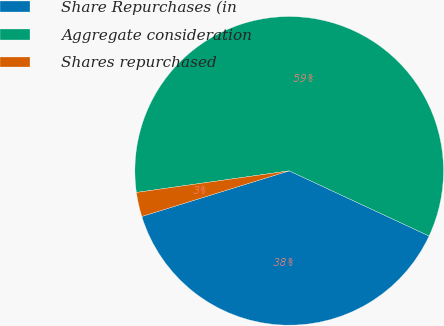Convert chart. <chart><loc_0><loc_0><loc_500><loc_500><pie_chart><fcel>Share Repurchases (in<fcel>Aggregate consideration<fcel>Shares repurchased<nl><fcel>38.29%<fcel>59.18%<fcel>2.54%<nl></chart> 